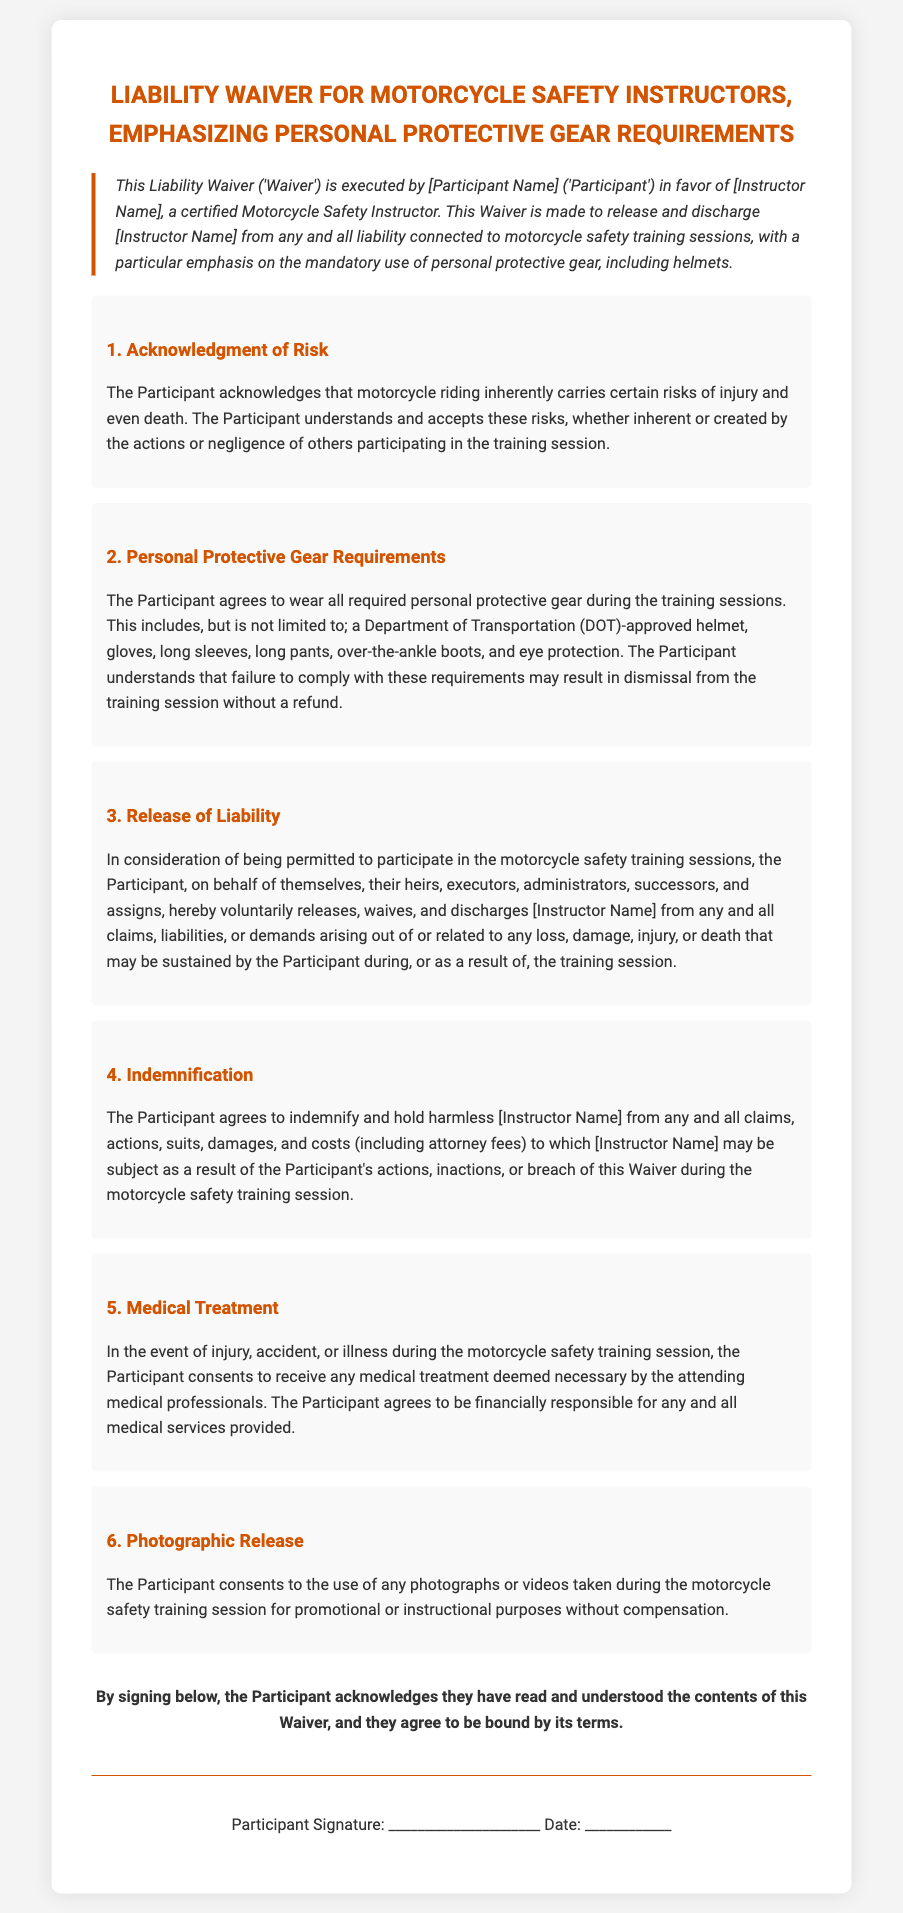What is the name of the Participant? The Participant's name is indicated as [Participant Name], which is a placeholder to be filled in.
Answer: [Participant Name] Who is the Instructor? The Instructor's name is indicated as [Instructor Name], which is a placeholder to be filled in.
Answer: [Instructor Name] What type of helmet is required? The document specifies that a Department of Transportation (DOT)-approved helmet is required.
Answer: DOT-approved helmet What must the Participant wear during the training sessions? The document lists mandatory personal protective gear, including a helmet, gloves, long sleeves, long pants, over-the-ankle boots, and eye protection.
Answer: All required personal protective gear What happens if the Participant fails to comply with the gear requirements? The document states that failure to comply may result in dismissal from the training session without a refund.
Answer: Dismissal without a refund What does the Participant release the Instructor from? The Participant releases the Instructor from any and all claims, liabilities, or demands arising out of or related to any loss, damage, injury, or death.
Answer: Any and all claims What is the Participant responsible for in the event of medical treatment? The document states that the Participant agrees to be financially responsible for any and all medical services provided.
Answer: Financially responsible for medical services What must the Participant do to acknowledge understanding of the Waiver? The Participant must sign below to acknowledge they have read and understood the contents of the Waiver.
Answer: Sign below What is the purpose of the photographic release? The release allows for the use of photographs or videos taken during the training session for promotional or instructional purposes.
Answer: Promotional or instructional purposes 